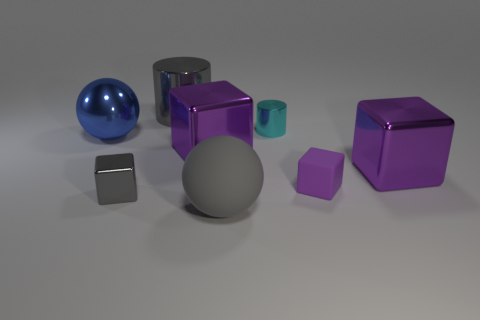There is a cylinder left of the large purple object on the left side of the cyan shiny object; is there a tiny cyan metal object that is left of it?
Give a very brief answer. No. What number of other objects are there of the same color as the large cylinder?
Your response must be concise. 2. There is a purple metallic cube that is to the left of the matte sphere; does it have the same size as the gray object that is to the right of the gray shiny cylinder?
Make the answer very short. Yes. Are there an equal number of large objects that are in front of the gray cylinder and big cubes in front of the gray rubber thing?
Provide a short and direct response. No. There is a metal ball; does it have the same size as the matte object that is on the left side of the cyan metallic object?
Keep it short and to the point. Yes. What material is the sphere to the right of the large purple metallic thing that is on the left side of the small metal cylinder made of?
Give a very brief answer. Rubber. Are there the same number of blue things that are right of the small gray shiny object and large purple metal things?
Ensure brevity in your answer.  No. There is a thing that is to the right of the rubber sphere and left of the tiny purple rubber block; how big is it?
Your answer should be compact. Small. There is a big sphere that is behind the large purple thing to the left of the large matte ball; what color is it?
Ensure brevity in your answer.  Blue. How many blue things are cylinders or big matte spheres?
Give a very brief answer. 0. 